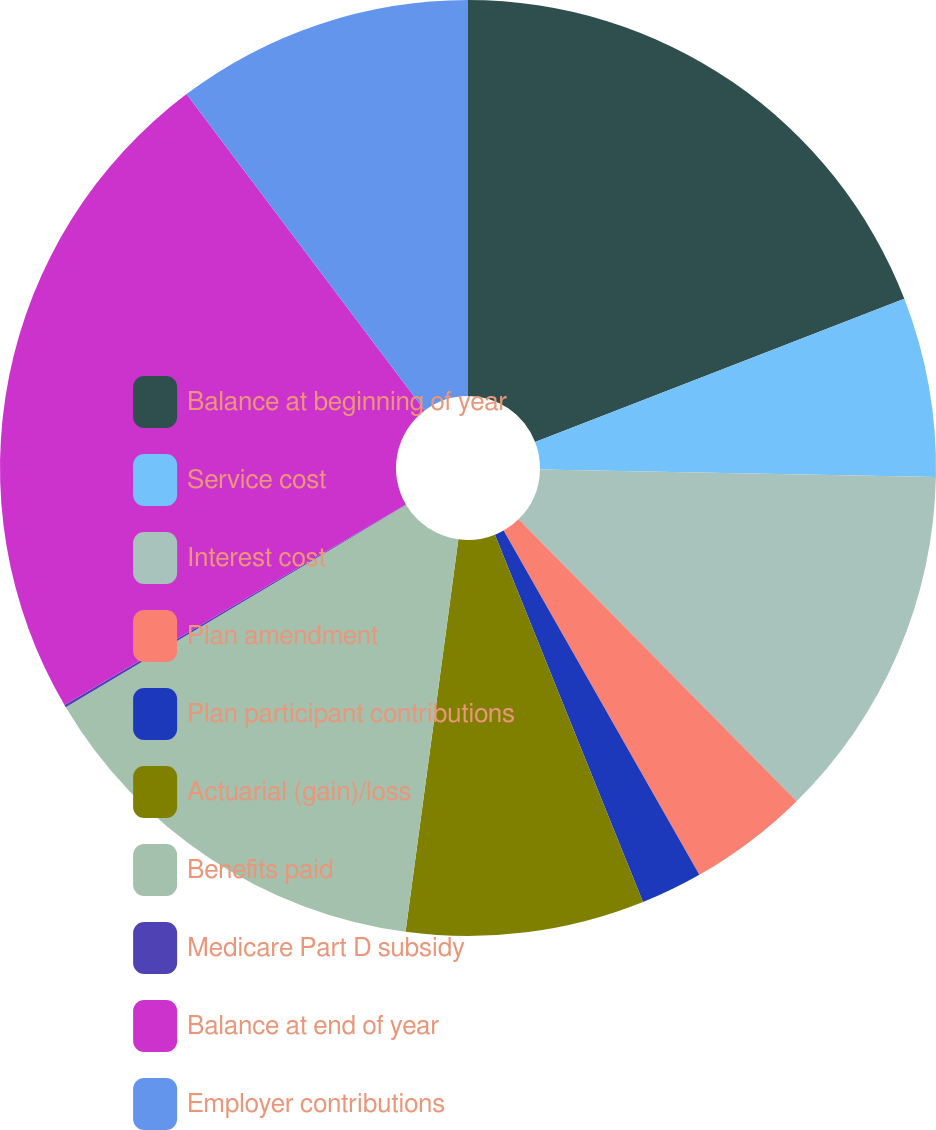Convert chart. <chart><loc_0><loc_0><loc_500><loc_500><pie_chart><fcel>Balance at beginning of year<fcel>Service cost<fcel>Interest cost<fcel>Plan amendment<fcel>Plan participant contributions<fcel>Actuarial (gain)/loss<fcel>Benefits paid<fcel>Medicare Part D subsidy<fcel>Balance at end of year<fcel>Employer contributions<nl><fcel>19.11%<fcel>6.2%<fcel>12.3%<fcel>4.16%<fcel>2.13%<fcel>8.23%<fcel>14.33%<fcel>0.09%<fcel>23.18%<fcel>10.27%<nl></chart> 